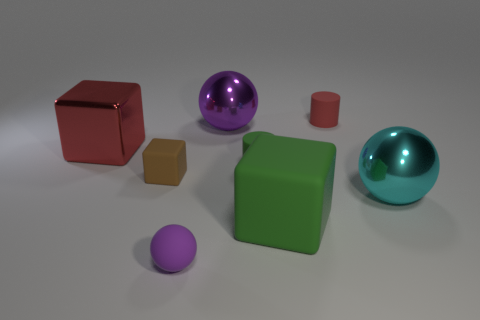Describe the lighting and shadows in the scene. The lighting appears to be soft and diffused, coming from above, casting gentle shadows that fall mostly to the right of the objects, indicating the light source is to the left in the image. 